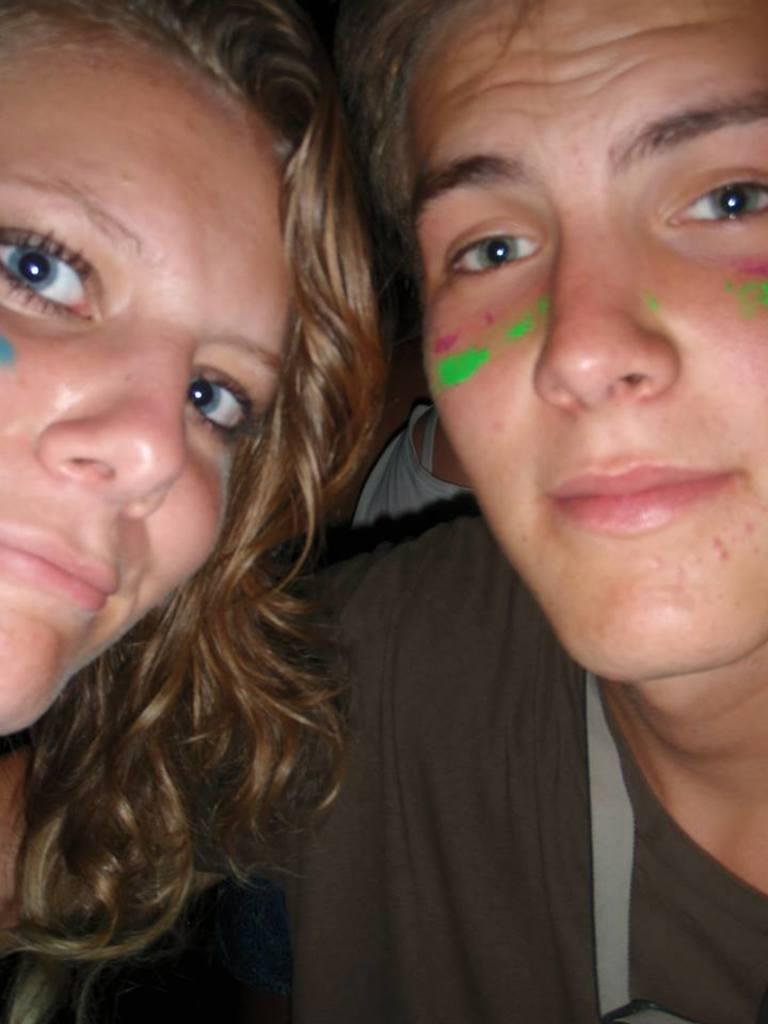How many people are in the image? There are two people in the image. What is a noticeable characteristic of the people in the image? The people have paint on them. What can be seen in the background of the image? There is a cloth visible in the background of the image. What level of education do the sisters in the image have? There is no mention of sisters in the image, and the level of education of the people in the image cannot be determined from the facts provided. 